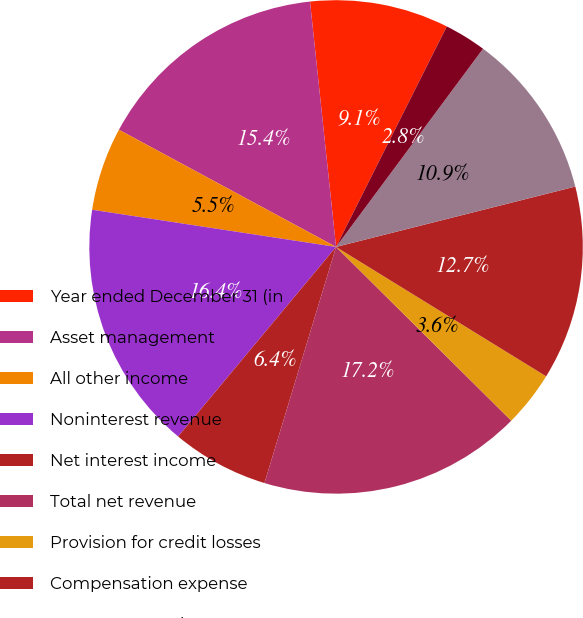Convert chart. <chart><loc_0><loc_0><loc_500><loc_500><pie_chart><fcel>Year ended December 31 (in<fcel>Asset management<fcel>All other income<fcel>Noninterest revenue<fcel>Net interest income<fcel>Total net revenue<fcel>Provision for credit losses<fcel>Compensation expense<fcel>Noncompensation expense<fcel>Amortization of intangibles<nl><fcel>9.09%<fcel>15.44%<fcel>5.47%<fcel>16.35%<fcel>6.37%<fcel>17.25%<fcel>3.65%<fcel>12.72%<fcel>10.91%<fcel>2.75%<nl></chart> 